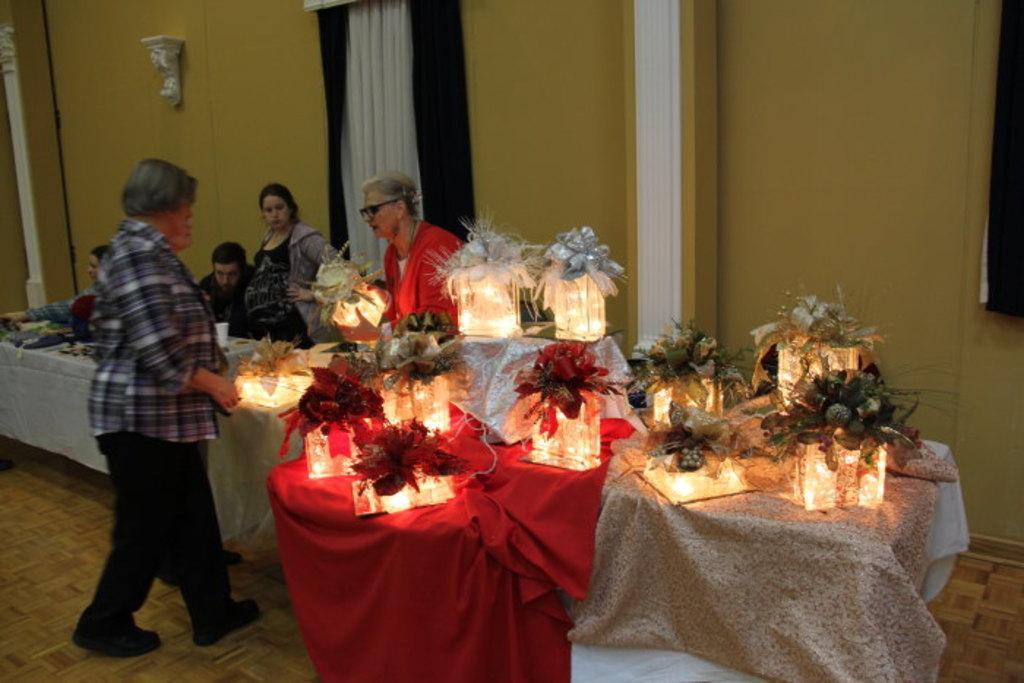Could you give a brief overview of what you see in this image? This picture is taken inside a room. There are few people in the room and there are tables and chairs. There is a cloth spread on table and boxes are kept that are decorated and lightning. In the background there is wall and curtain. 